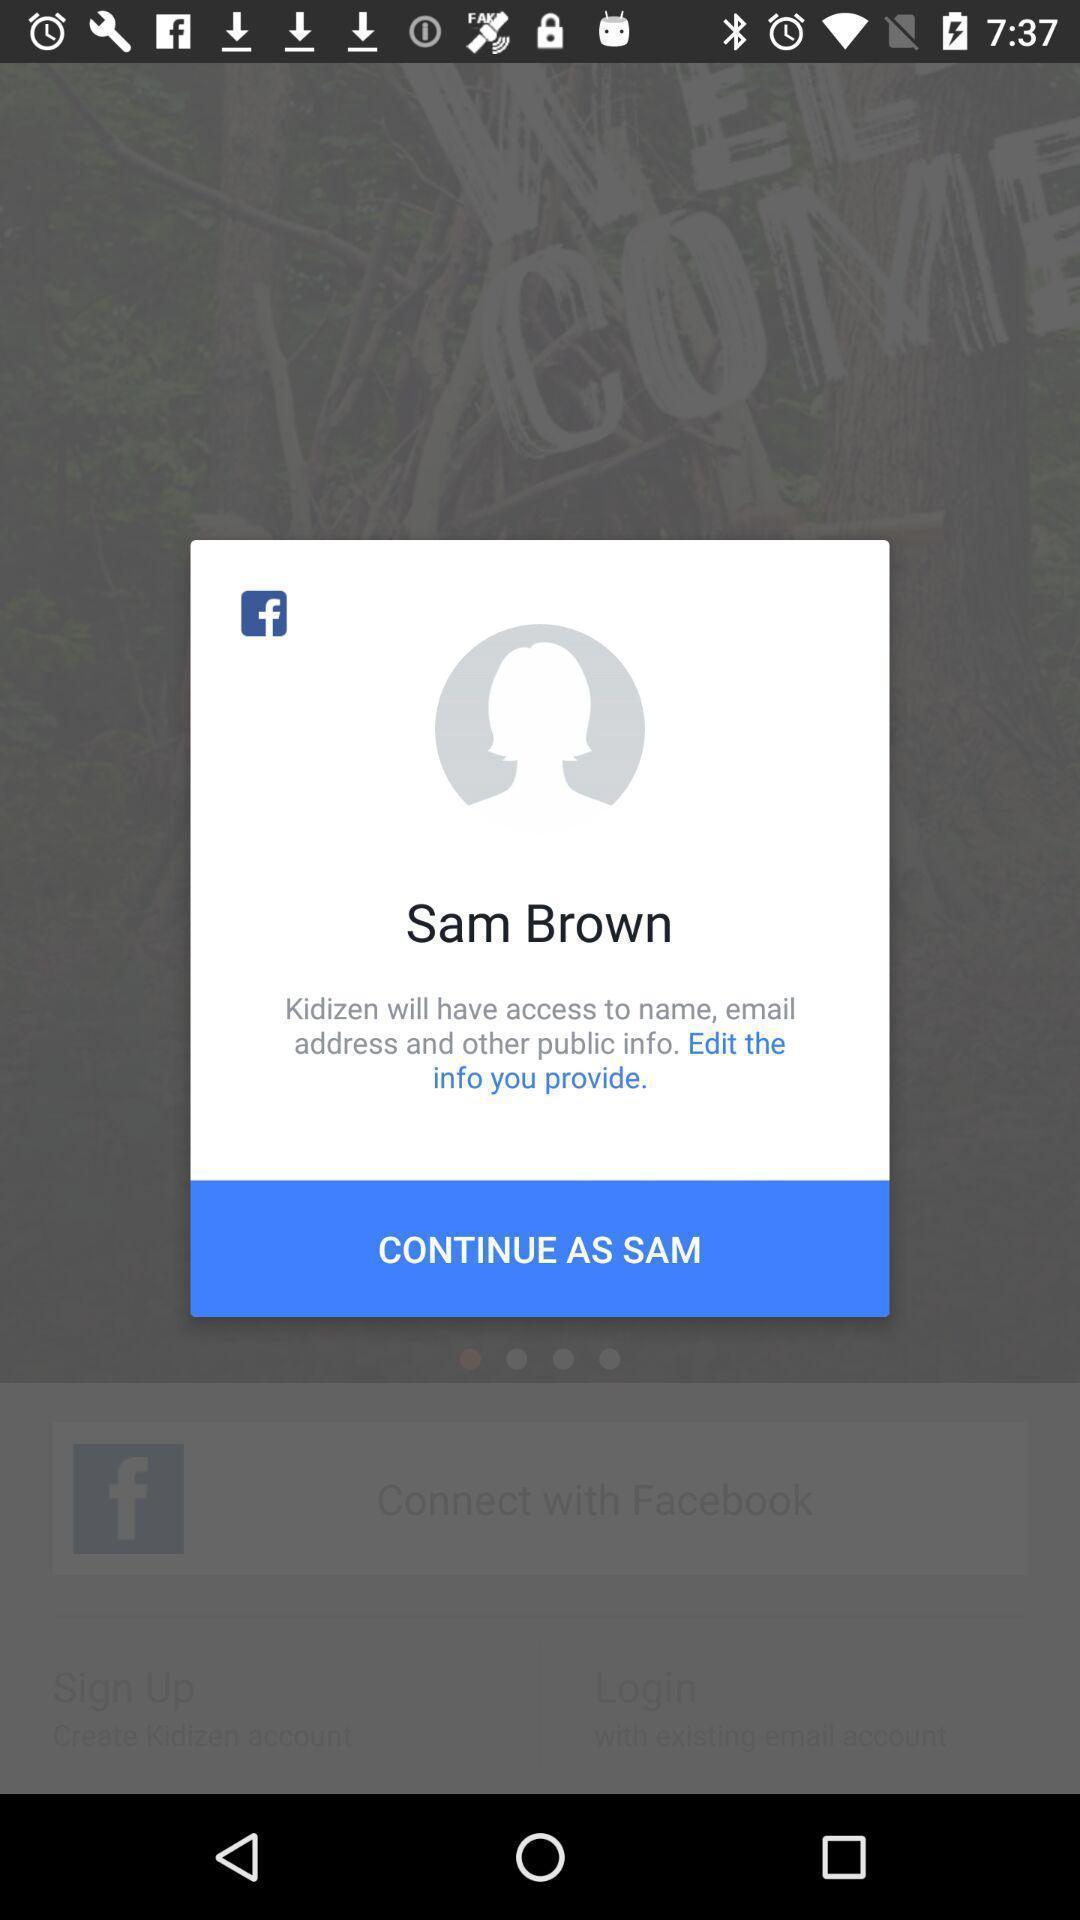Tell me about the visual elements in this screen capture. Pop-up message asking to continue. 